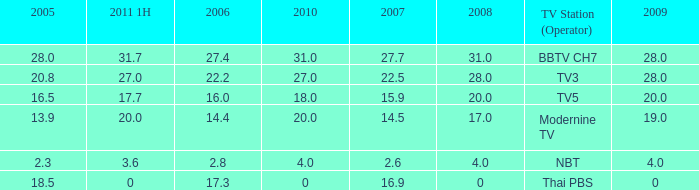What is the average 2007 value for a 2006 of 2.8 and 2009 under 20? 2.6. 